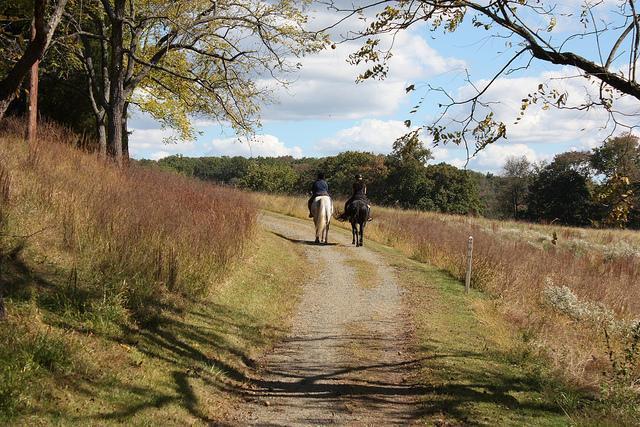What animals are present?
Choose the correct response and explain in the format: 'Answer: answer
Rationale: rationale.'
Options: Horse, dog, deer, giraffe. Answer: horse.
Rationale: Two horses are a little ways up the dirt road, and both are being ridden today by their respective owners. 